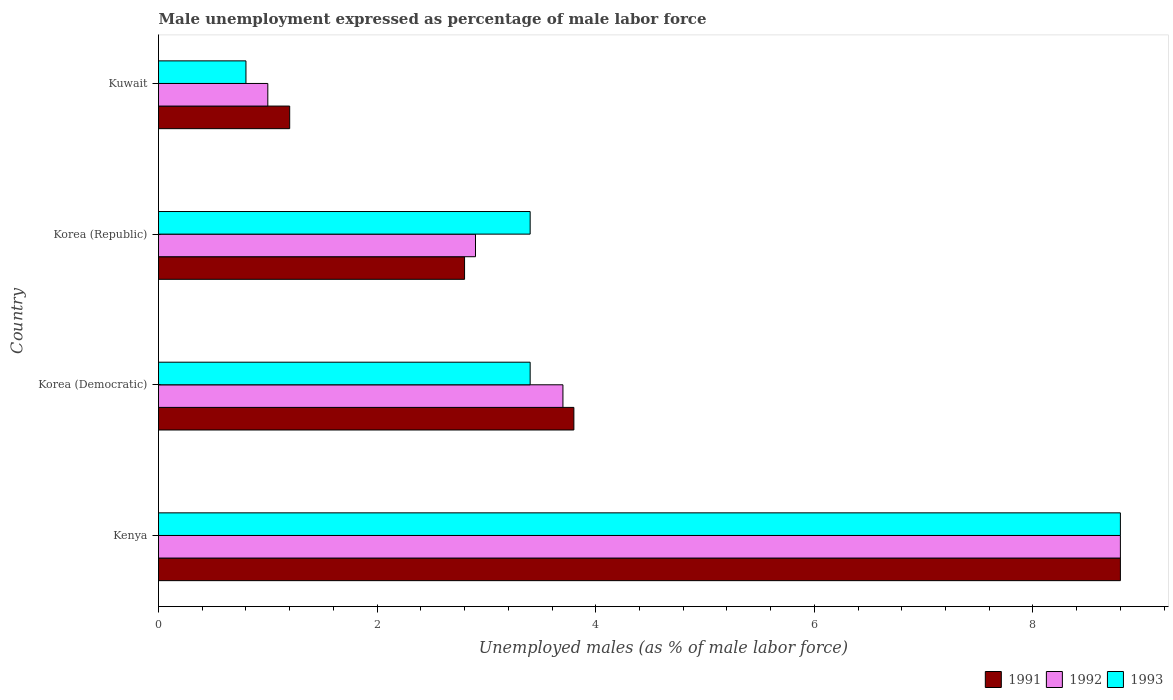How many different coloured bars are there?
Make the answer very short. 3. Are the number of bars on each tick of the Y-axis equal?
Provide a succinct answer. Yes. How many bars are there on the 2nd tick from the top?
Offer a very short reply. 3. What is the label of the 2nd group of bars from the top?
Your response must be concise. Korea (Republic). In how many cases, is the number of bars for a given country not equal to the number of legend labels?
Offer a terse response. 0. What is the unemployment in males in in 1993 in Korea (Republic)?
Make the answer very short. 3.4. Across all countries, what is the maximum unemployment in males in in 1993?
Keep it short and to the point. 8.8. Across all countries, what is the minimum unemployment in males in in 1993?
Provide a succinct answer. 0.8. In which country was the unemployment in males in in 1991 maximum?
Offer a terse response. Kenya. In which country was the unemployment in males in in 1991 minimum?
Your response must be concise. Kuwait. What is the total unemployment in males in in 1991 in the graph?
Offer a very short reply. 16.6. What is the difference between the unemployment in males in in 1992 in Korea (Democratic) and that in Korea (Republic)?
Provide a succinct answer. 0.8. What is the difference between the unemployment in males in in 1991 in Korea (Democratic) and the unemployment in males in in 1992 in Korea (Republic)?
Your response must be concise. 0.9. What is the average unemployment in males in in 1991 per country?
Offer a very short reply. 4.15. What is the difference between the unemployment in males in in 1992 and unemployment in males in in 1993 in Korea (Democratic)?
Ensure brevity in your answer.  0.3. Is the unemployment in males in in 1993 in Korea (Democratic) less than that in Korea (Republic)?
Provide a short and direct response. No. What is the difference between the highest and the second highest unemployment in males in in 1993?
Provide a short and direct response. 5.4. What is the difference between the highest and the lowest unemployment in males in in 1991?
Provide a succinct answer. 7.6. In how many countries, is the unemployment in males in in 1991 greater than the average unemployment in males in in 1991 taken over all countries?
Give a very brief answer. 1. How many bars are there?
Ensure brevity in your answer.  12. Are all the bars in the graph horizontal?
Give a very brief answer. Yes. What is the difference between two consecutive major ticks on the X-axis?
Your answer should be very brief. 2. Are the values on the major ticks of X-axis written in scientific E-notation?
Your answer should be compact. No. Does the graph contain any zero values?
Make the answer very short. No. Where does the legend appear in the graph?
Ensure brevity in your answer.  Bottom right. How are the legend labels stacked?
Offer a terse response. Horizontal. What is the title of the graph?
Offer a terse response. Male unemployment expressed as percentage of male labor force. Does "1993" appear as one of the legend labels in the graph?
Offer a very short reply. Yes. What is the label or title of the X-axis?
Keep it short and to the point. Unemployed males (as % of male labor force). What is the label or title of the Y-axis?
Your answer should be very brief. Country. What is the Unemployed males (as % of male labor force) in 1991 in Kenya?
Your answer should be very brief. 8.8. What is the Unemployed males (as % of male labor force) in 1992 in Kenya?
Provide a succinct answer. 8.8. What is the Unemployed males (as % of male labor force) of 1993 in Kenya?
Offer a terse response. 8.8. What is the Unemployed males (as % of male labor force) in 1991 in Korea (Democratic)?
Give a very brief answer. 3.8. What is the Unemployed males (as % of male labor force) of 1992 in Korea (Democratic)?
Keep it short and to the point. 3.7. What is the Unemployed males (as % of male labor force) of 1993 in Korea (Democratic)?
Give a very brief answer. 3.4. What is the Unemployed males (as % of male labor force) of 1991 in Korea (Republic)?
Offer a very short reply. 2.8. What is the Unemployed males (as % of male labor force) in 1992 in Korea (Republic)?
Your answer should be very brief. 2.9. What is the Unemployed males (as % of male labor force) of 1993 in Korea (Republic)?
Give a very brief answer. 3.4. What is the Unemployed males (as % of male labor force) of 1991 in Kuwait?
Your answer should be compact. 1.2. What is the Unemployed males (as % of male labor force) of 1992 in Kuwait?
Your response must be concise. 1. What is the Unemployed males (as % of male labor force) of 1993 in Kuwait?
Ensure brevity in your answer.  0.8. Across all countries, what is the maximum Unemployed males (as % of male labor force) of 1991?
Keep it short and to the point. 8.8. Across all countries, what is the maximum Unemployed males (as % of male labor force) in 1992?
Your answer should be very brief. 8.8. Across all countries, what is the maximum Unemployed males (as % of male labor force) in 1993?
Offer a terse response. 8.8. Across all countries, what is the minimum Unemployed males (as % of male labor force) of 1991?
Give a very brief answer. 1.2. Across all countries, what is the minimum Unemployed males (as % of male labor force) of 1993?
Your answer should be very brief. 0.8. What is the total Unemployed males (as % of male labor force) of 1991 in the graph?
Offer a terse response. 16.6. What is the total Unemployed males (as % of male labor force) of 1992 in the graph?
Offer a terse response. 16.4. What is the total Unemployed males (as % of male labor force) of 1993 in the graph?
Provide a succinct answer. 16.4. What is the difference between the Unemployed males (as % of male labor force) in 1991 in Kenya and that in Korea (Democratic)?
Your answer should be compact. 5. What is the difference between the Unemployed males (as % of male labor force) of 1991 in Kenya and that in Korea (Republic)?
Your answer should be very brief. 6. What is the difference between the Unemployed males (as % of male labor force) in 1992 in Kenya and that in Korea (Republic)?
Provide a short and direct response. 5.9. What is the difference between the Unemployed males (as % of male labor force) in 1991 in Kenya and that in Kuwait?
Your answer should be very brief. 7.6. What is the difference between the Unemployed males (as % of male labor force) of 1992 in Kenya and that in Kuwait?
Your answer should be very brief. 7.8. What is the difference between the Unemployed males (as % of male labor force) of 1993 in Kenya and that in Kuwait?
Your response must be concise. 8. What is the difference between the Unemployed males (as % of male labor force) of 1993 in Korea (Democratic) and that in Korea (Republic)?
Offer a very short reply. 0. What is the difference between the Unemployed males (as % of male labor force) of 1991 in Korea (Democratic) and that in Kuwait?
Provide a succinct answer. 2.6. What is the difference between the Unemployed males (as % of male labor force) of 1992 in Korea (Democratic) and that in Kuwait?
Provide a succinct answer. 2.7. What is the difference between the Unemployed males (as % of male labor force) of 1991 in Korea (Republic) and that in Kuwait?
Your answer should be compact. 1.6. What is the difference between the Unemployed males (as % of male labor force) in 1993 in Korea (Republic) and that in Kuwait?
Your answer should be very brief. 2.6. What is the difference between the Unemployed males (as % of male labor force) in 1991 in Kenya and the Unemployed males (as % of male labor force) in 1993 in Korea (Democratic)?
Offer a terse response. 5.4. What is the difference between the Unemployed males (as % of male labor force) of 1991 in Kenya and the Unemployed males (as % of male labor force) of 1993 in Korea (Republic)?
Provide a short and direct response. 5.4. What is the difference between the Unemployed males (as % of male labor force) of 1992 in Kenya and the Unemployed males (as % of male labor force) of 1993 in Kuwait?
Your answer should be compact. 8. What is the difference between the Unemployed males (as % of male labor force) of 1991 in Korea (Democratic) and the Unemployed males (as % of male labor force) of 1992 in Korea (Republic)?
Your response must be concise. 0.9. What is the difference between the Unemployed males (as % of male labor force) in 1991 in Korea (Democratic) and the Unemployed males (as % of male labor force) in 1993 in Korea (Republic)?
Provide a short and direct response. 0.4. What is the difference between the Unemployed males (as % of male labor force) in 1991 in Korea (Democratic) and the Unemployed males (as % of male labor force) in 1993 in Kuwait?
Keep it short and to the point. 3. What is the difference between the Unemployed males (as % of male labor force) of 1992 in Korea (Democratic) and the Unemployed males (as % of male labor force) of 1993 in Kuwait?
Provide a short and direct response. 2.9. What is the difference between the Unemployed males (as % of male labor force) in 1992 in Korea (Republic) and the Unemployed males (as % of male labor force) in 1993 in Kuwait?
Your answer should be very brief. 2.1. What is the average Unemployed males (as % of male labor force) in 1991 per country?
Your response must be concise. 4.15. What is the average Unemployed males (as % of male labor force) in 1993 per country?
Provide a short and direct response. 4.1. What is the difference between the Unemployed males (as % of male labor force) in 1991 and Unemployed males (as % of male labor force) in 1992 in Korea (Democratic)?
Your answer should be very brief. 0.1. What is the difference between the Unemployed males (as % of male labor force) in 1991 and Unemployed males (as % of male labor force) in 1992 in Korea (Republic)?
Your answer should be compact. -0.1. What is the difference between the Unemployed males (as % of male labor force) in 1991 and Unemployed males (as % of male labor force) in 1993 in Korea (Republic)?
Provide a short and direct response. -0.6. What is the difference between the Unemployed males (as % of male labor force) of 1991 and Unemployed males (as % of male labor force) of 1992 in Kuwait?
Your response must be concise. 0.2. What is the difference between the Unemployed males (as % of male labor force) in 1991 and Unemployed males (as % of male labor force) in 1993 in Kuwait?
Your answer should be very brief. 0.4. What is the difference between the Unemployed males (as % of male labor force) in 1992 and Unemployed males (as % of male labor force) in 1993 in Kuwait?
Your answer should be compact. 0.2. What is the ratio of the Unemployed males (as % of male labor force) of 1991 in Kenya to that in Korea (Democratic)?
Make the answer very short. 2.32. What is the ratio of the Unemployed males (as % of male labor force) of 1992 in Kenya to that in Korea (Democratic)?
Offer a very short reply. 2.38. What is the ratio of the Unemployed males (as % of male labor force) of 1993 in Kenya to that in Korea (Democratic)?
Ensure brevity in your answer.  2.59. What is the ratio of the Unemployed males (as % of male labor force) of 1991 in Kenya to that in Korea (Republic)?
Give a very brief answer. 3.14. What is the ratio of the Unemployed males (as % of male labor force) in 1992 in Kenya to that in Korea (Republic)?
Offer a terse response. 3.03. What is the ratio of the Unemployed males (as % of male labor force) in 1993 in Kenya to that in Korea (Republic)?
Offer a very short reply. 2.59. What is the ratio of the Unemployed males (as % of male labor force) of 1991 in Kenya to that in Kuwait?
Make the answer very short. 7.33. What is the ratio of the Unemployed males (as % of male labor force) in 1991 in Korea (Democratic) to that in Korea (Republic)?
Keep it short and to the point. 1.36. What is the ratio of the Unemployed males (as % of male labor force) of 1992 in Korea (Democratic) to that in Korea (Republic)?
Offer a terse response. 1.28. What is the ratio of the Unemployed males (as % of male labor force) in 1993 in Korea (Democratic) to that in Korea (Republic)?
Offer a very short reply. 1. What is the ratio of the Unemployed males (as % of male labor force) in 1991 in Korea (Democratic) to that in Kuwait?
Keep it short and to the point. 3.17. What is the ratio of the Unemployed males (as % of male labor force) of 1992 in Korea (Democratic) to that in Kuwait?
Offer a very short reply. 3.7. What is the ratio of the Unemployed males (as % of male labor force) in 1993 in Korea (Democratic) to that in Kuwait?
Give a very brief answer. 4.25. What is the ratio of the Unemployed males (as % of male labor force) in 1991 in Korea (Republic) to that in Kuwait?
Provide a short and direct response. 2.33. What is the ratio of the Unemployed males (as % of male labor force) of 1992 in Korea (Republic) to that in Kuwait?
Your answer should be compact. 2.9. What is the ratio of the Unemployed males (as % of male labor force) of 1993 in Korea (Republic) to that in Kuwait?
Provide a succinct answer. 4.25. What is the difference between the highest and the second highest Unemployed males (as % of male labor force) of 1992?
Your response must be concise. 5.1. What is the difference between the highest and the second highest Unemployed males (as % of male labor force) of 1993?
Provide a succinct answer. 5.4. What is the difference between the highest and the lowest Unemployed males (as % of male labor force) of 1992?
Make the answer very short. 7.8. 